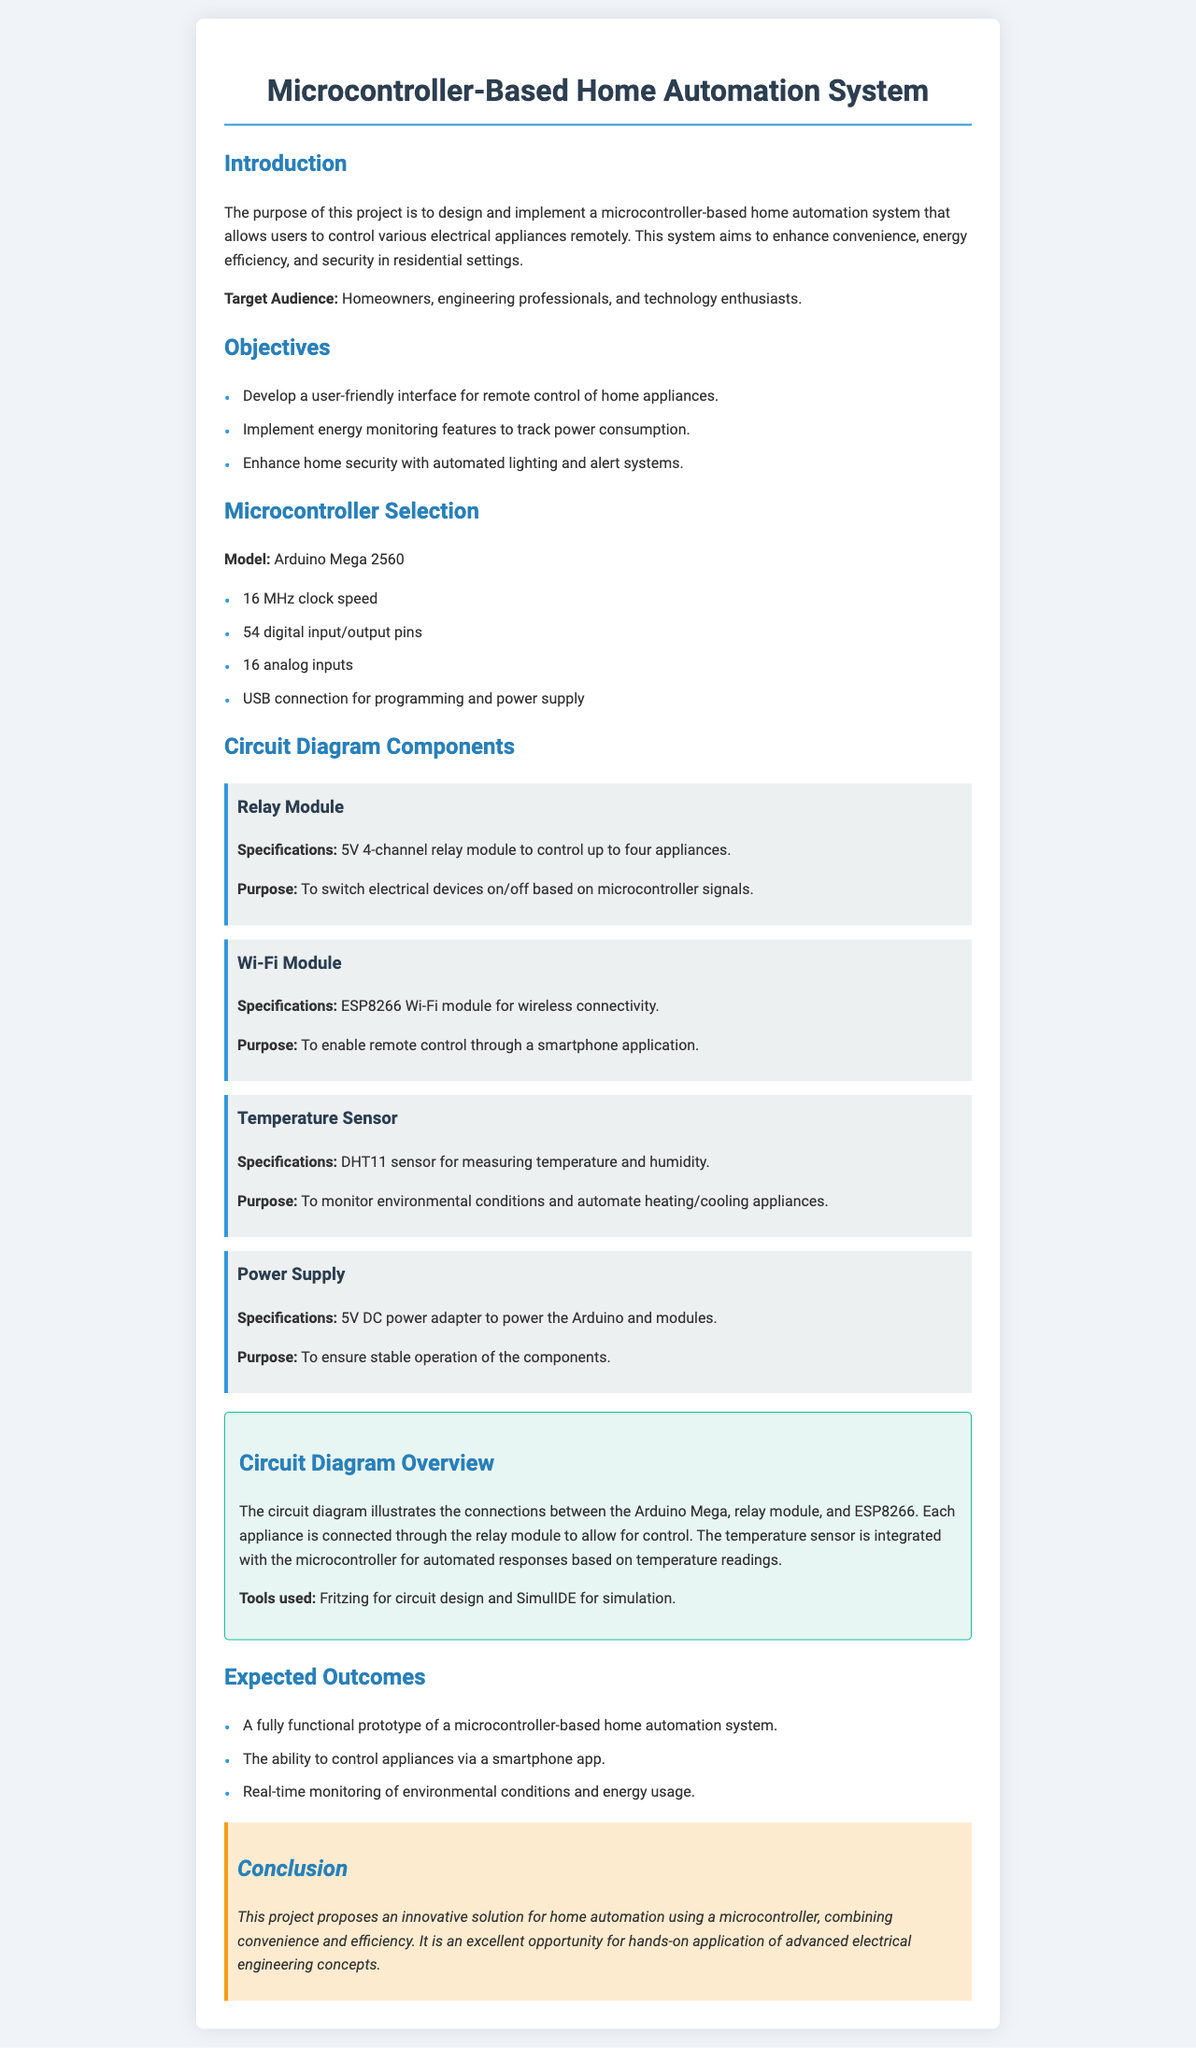What is the model of the microcontroller? The document specifies that the microcontroller model is the Arduino Mega 2560.
Answer: Arduino Mega 2560 How many digital input/output pins does the Arduino Mega 2560 have? The document states that the Arduino Mega 2560 has 54 digital input/output pins.
Answer: 54 What sensor is used for measuring temperature and humidity? The document mentions that the DHT11 sensor is used for measuring temperature and humidity.
Answer: DHT11 What is the purpose of the relay module? The purpose of the relay module is to switch electrical devices on/off based on microcontroller signals.
Answer: To switch electrical devices on/off What is one expected outcome of the project? The document lists several expected outcomes, including the ability to control appliances via a smartphone app.
Answer: Control appliances via a smartphone app What is the power supply specification? The document indicates that a 5V DC power adapter is used to power the Arduino and modules.
Answer: 5V DC power adapter What tool is used for circuit design? The document states that Fritzing is used for circuit design.
Answer: Fritzing How does the system contribute to energy efficiency? The project aims to implement energy monitoring features to track power consumption, contributing to energy efficiency.
Answer: Energy monitoring features What is the target audience for the project? The document describes the target audience as homeowners, engineering professionals, and technology enthusiasts.
Answer: Homeowners, engineering professionals, and technology enthusiasts 